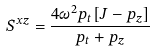Convert formula to latex. <formula><loc_0><loc_0><loc_500><loc_500>S ^ { x z } = \frac { 4 { \omega } ^ { 2 } p _ { t } [ J - p _ { z } ] } { p _ { t } + p _ { z } }</formula> 